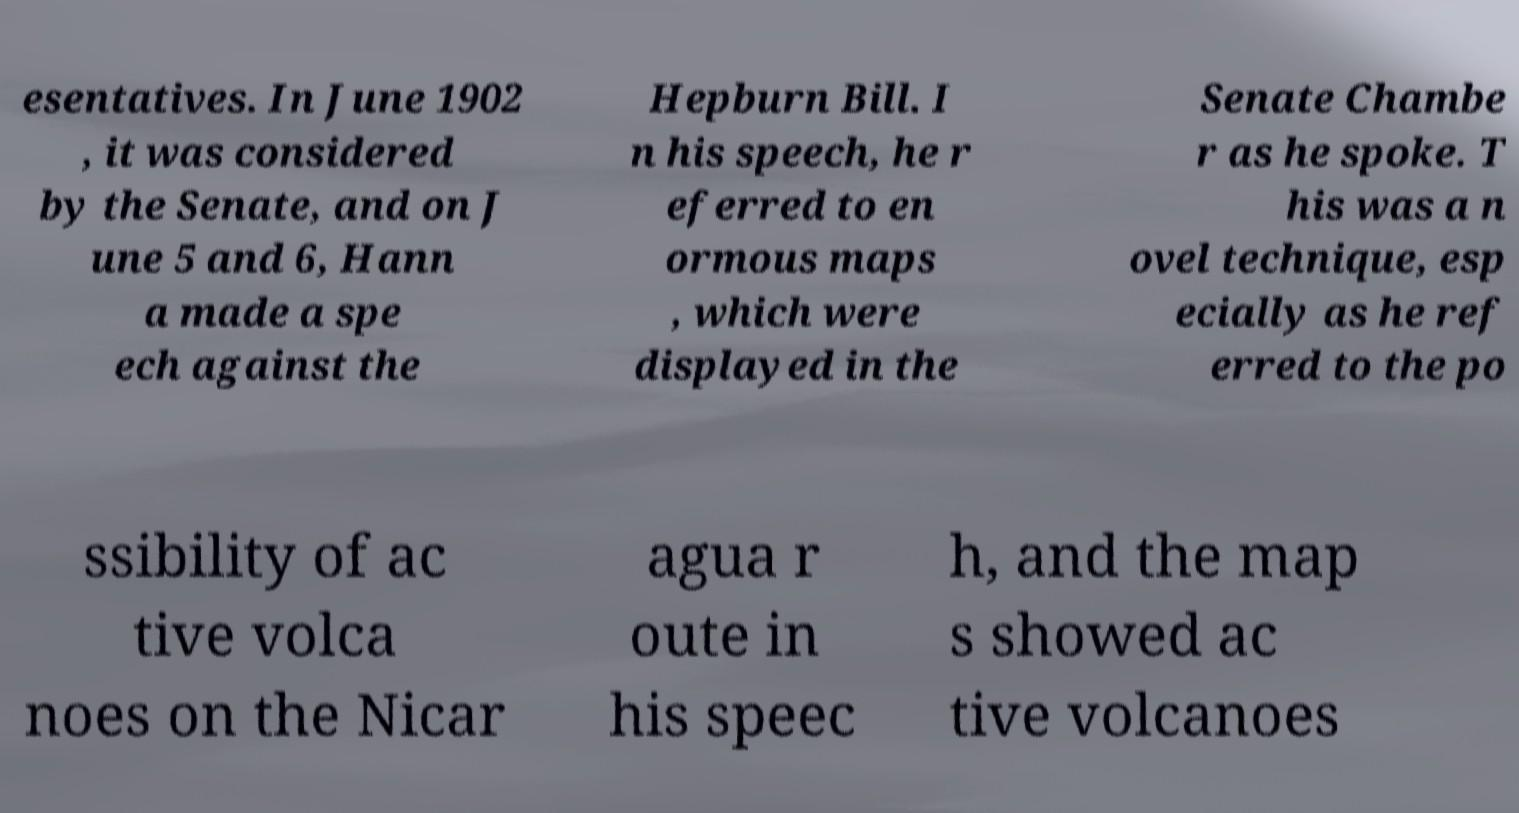I need the written content from this picture converted into text. Can you do that? esentatives. In June 1902 , it was considered by the Senate, and on J une 5 and 6, Hann a made a spe ech against the Hepburn Bill. I n his speech, he r eferred to en ormous maps , which were displayed in the Senate Chambe r as he spoke. T his was a n ovel technique, esp ecially as he ref erred to the po ssibility of ac tive volca noes on the Nicar agua r oute in his speec h, and the map s showed ac tive volcanoes 